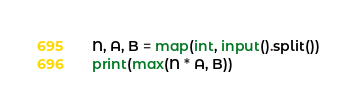Convert code to text. <code><loc_0><loc_0><loc_500><loc_500><_Python_>N, A, B = map(int, input().split())
print(max(N * A, B))</code> 